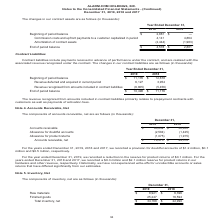According to Alarmcom Holdings's financial document, What did contract liabilities include? payments received in advance of performance under the contract, and are realized with the associated revenue recognized under the contract.. The document states: "Contract liabilities include payments received in advance of performance under the contract, and are realized with the associated revenue recognized u..." Also, What did the revenue recognized from amounts included in contract liabilities primarily related to? prepayment contracts with customers as well as payments of activation fees.. The document states: "luded in contract liabilities primarily relates to prepayment contracts with customers as well as payments of activation fees...." Also, Which years does the table provide information for the changes in the company's contract liabilities? The document shows two values: 2019 and 2018. From the document: "Year Ended December 31, 2019 2018 Beginning of period balance $ 2,881 $ — Commission costs and upfront payments to a customer ca Year Ended December 3..." Also, can you calculate: What was the change in Revenue deferred and acquired in current period between 2018 and 2019? Based on the calculation: 6,127-3,954, the result is 2173 (in thousands). This is based on the information: "nue deferred and acquired in current period 6,127 3,954 Revenue recognized from amounts included in contract liabilities (6,805) (5,456) End of period bala 8 Revenue deferred and acquired in current p..." The key data points involved are: 3,954, 6,127. Also, How many years did the Beginning of period balance exceed $11,000 thousand? Counting the relevant items in the document: 2019, 2018, I find 2 instances. The key data points involved are: 2018, 2019. Also, can you calculate: What was the percentage change in the End of period balance between 2018 and 2019? To answer this question, I need to perform calculations using the financial data. The calculation is: (10,498-11,176)/11,176, which equals -6.07 (percentage). This is based on the information: "abilities (6,805) (5,456) End of period balance $ 10,498 $ 11,176 ember 31, 2019 2018 Beginning of period balance $ 11,176 $ 12,678 Revenue deferred and acquired in current period 6,127 3,954 Revenue ..." The key data points involved are: 10,498, 11,176. 